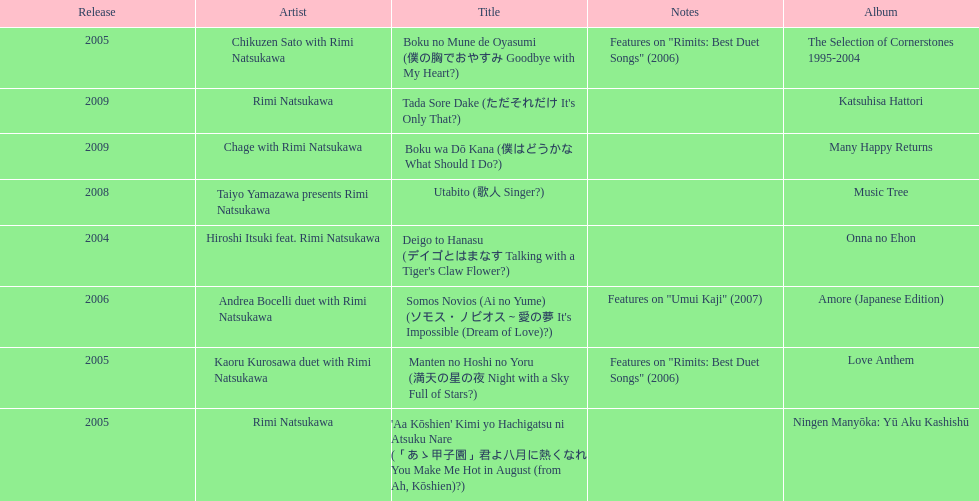What has been the last song this artist has made an other appearance on? Tada Sore Dake. 